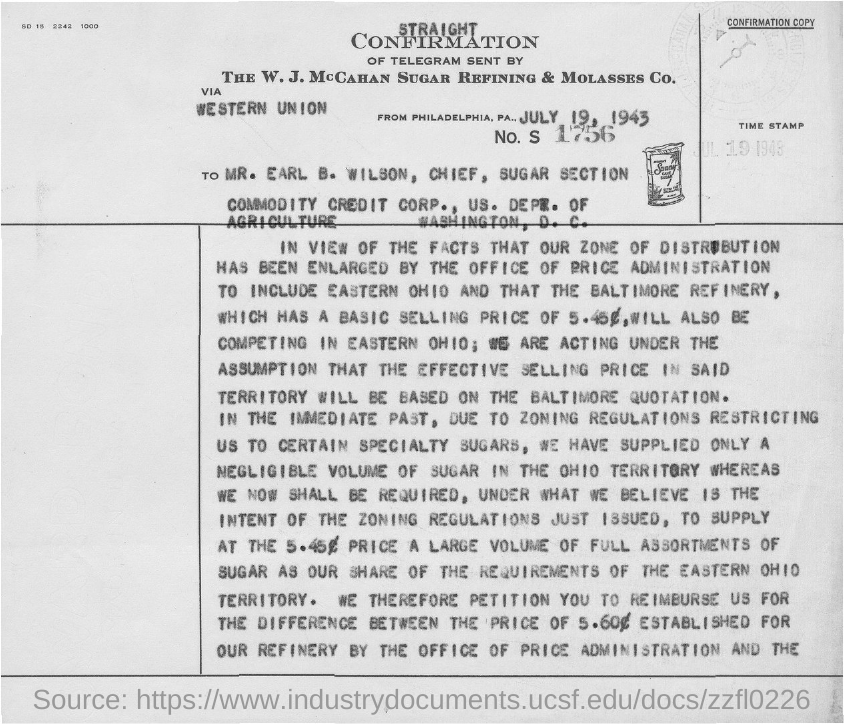What is the time stamp mentioned in the given form ?
Your answer should be compact. Jul 19 1943. What is the no. s mentioned in the given form ?
Keep it short and to the point. 1756. 